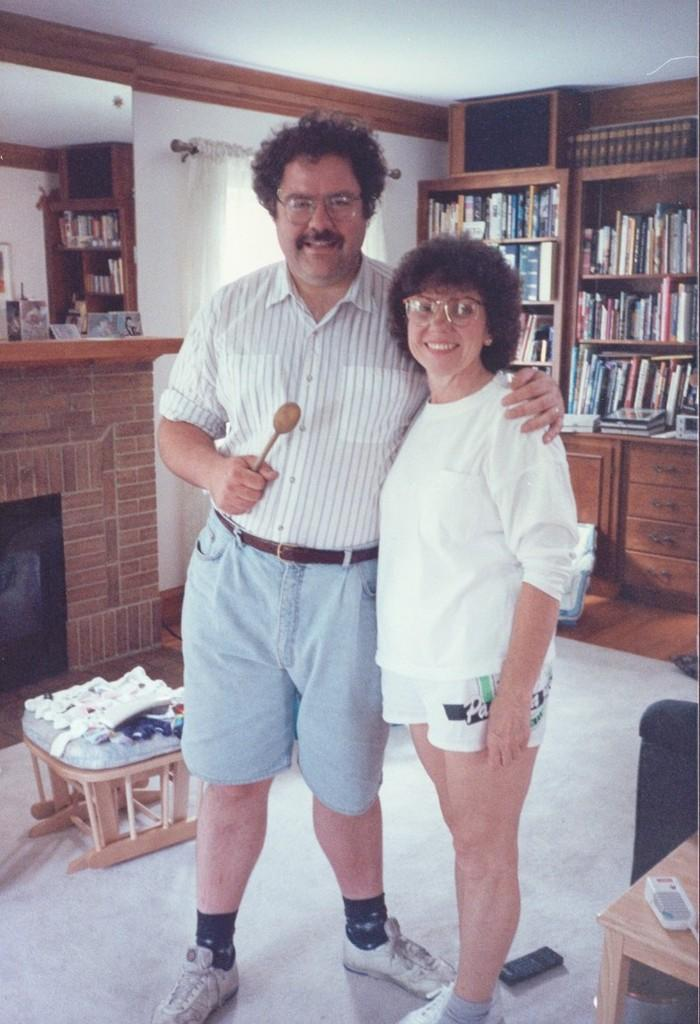How many people are in the image? There are two people in the image, a man and a woman. What are the man and the woman doing in the image? Both the man and the woman are standing and smiling. What can be seen in the background of the image? There is a rack full of books, a table, and a wall in the background. Can you tell me who created the ants in the image? There are no ants present in the image, so it is not possible to determine who created them. 